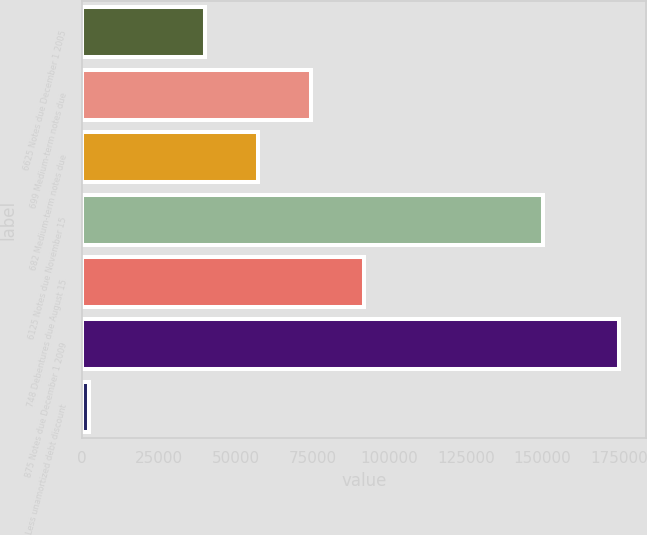<chart> <loc_0><loc_0><loc_500><loc_500><bar_chart><fcel>6625 Notes due December 1 2005<fcel>699 Medium-term notes due<fcel>682 Medium-term notes due<fcel>6125 Notes due November 15<fcel>748 Debentures due August 15<fcel>875 Notes due December 1 2009<fcel>Less unamortized debt discount<nl><fcel>40000<fcel>74550<fcel>57275<fcel>150000<fcel>91825<fcel>175000<fcel>2250<nl></chart> 